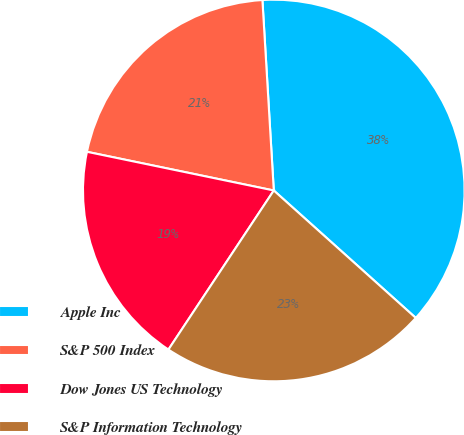Convert chart to OTSL. <chart><loc_0><loc_0><loc_500><loc_500><pie_chart><fcel>Apple Inc<fcel>S&P 500 Index<fcel>Dow Jones US Technology<fcel>S&P Information Technology<nl><fcel>37.59%<fcel>20.8%<fcel>18.94%<fcel>22.67%<nl></chart> 